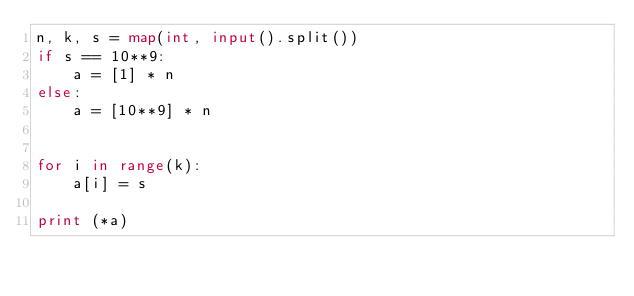Convert code to text. <code><loc_0><loc_0><loc_500><loc_500><_Python_>n, k, s = map(int, input().split())
if s == 10**9:
	a = [1] * n
else:
	a = [10**9] * n


for i in range(k):
	a[i] = s

print (*a)</code> 